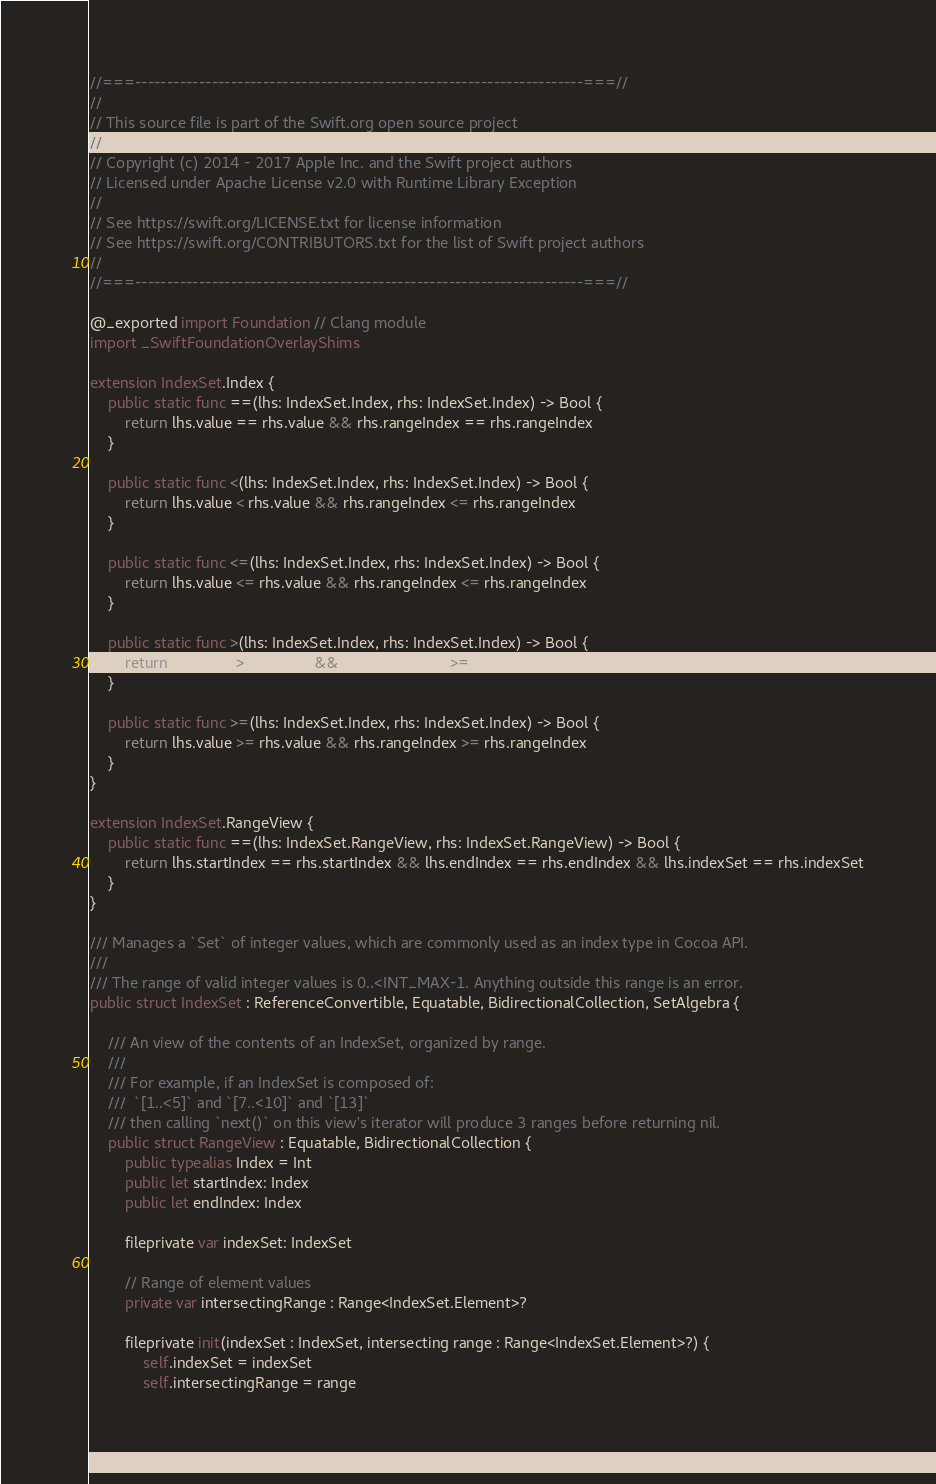<code> <loc_0><loc_0><loc_500><loc_500><_Swift_>//===----------------------------------------------------------------------===//
//
// This source file is part of the Swift.org open source project
//
// Copyright (c) 2014 - 2017 Apple Inc. and the Swift project authors
// Licensed under Apache License v2.0 with Runtime Library Exception
//
// See https://swift.org/LICENSE.txt for license information
// See https://swift.org/CONTRIBUTORS.txt for the list of Swift project authors
//
//===----------------------------------------------------------------------===//

@_exported import Foundation // Clang module
import _SwiftFoundationOverlayShims

extension IndexSet.Index {
    public static func ==(lhs: IndexSet.Index, rhs: IndexSet.Index) -> Bool {
        return lhs.value == rhs.value && rhs.rangeIndex == rhs.rangeIndex
    }

    public static func <(lhs: IndexSet.Index, rhs: IndexSet.Index) -> Bool {
        return lhs.value < rhs.value && rhs.rangeIndex <= rhs.rangeIndex
    }

    public static func <=(lhs: IndexSet.Index, rhs: IndexSet.Index) -> Bool {
        return lhs.value <= rhs.value && rhs.rangeIndex <= rhs.rangeIndex
    }

    public static func >(lhs: IndexSet.Index, rhs: IndexSet.Index) -> Bool {
        return lhs.value > rhs.value && rhs.rangeIndex >= rhs.rangeIndex
    }

    public static func >=(lhs: IndexSet.Index, rhs: IndexSet.Index) -> Bool {
        return lhs.value >= rhs.value && rhs.rangeIndex >= rhs.rangeIndex
    }
}

extension IndexSet.RangeView {
    public static func ==(lhs: IndexSet.RangeView, rhs: IndexSet.RangeView) -> Bool {
        return lhs.startIndex == rhs.startIndex && lhs.endIndex == rhs.endIndex && lhs.indexSet == rhs.indexSet
    }
}

/// Manages a `Set` of integer values, which are commonly used as an index type in Cocoa API.
///
/// The range of valid integer values is 0..<INT_MAX-1. Anything outside this range is an error.
public struct IndexSet : ReferenceConvertible, Equatable, BidirectionalCollection, SetAlgebra {
    
    /// An view of the contents of an IndexSet, organized by range.
    ///
    /// For example, if an IndexSet is composed of:
    ///  `[1..<5]` and `[7..<10]` and `[13]`
    /// then calling `next()` on this view's iterator will produce 3 ranges before returning nil.
    public struct RangeView : Equatable, BidirectionalCollection {
        public typealias Index = Int
        public let startIndex: Index
        public let endIndex: Index
        
        fileprivate var indexSet: IndexSet
        
        // Range of element values
        private var intersectingRange : Range<IndexSet.Element>?
        
        fileprivate init(indexSet : IndexSet, intersecting range : Range<IndexSet.Element>?) {
            self.indexSet = indexSet
            self.intersectingRange = range
            </code> 